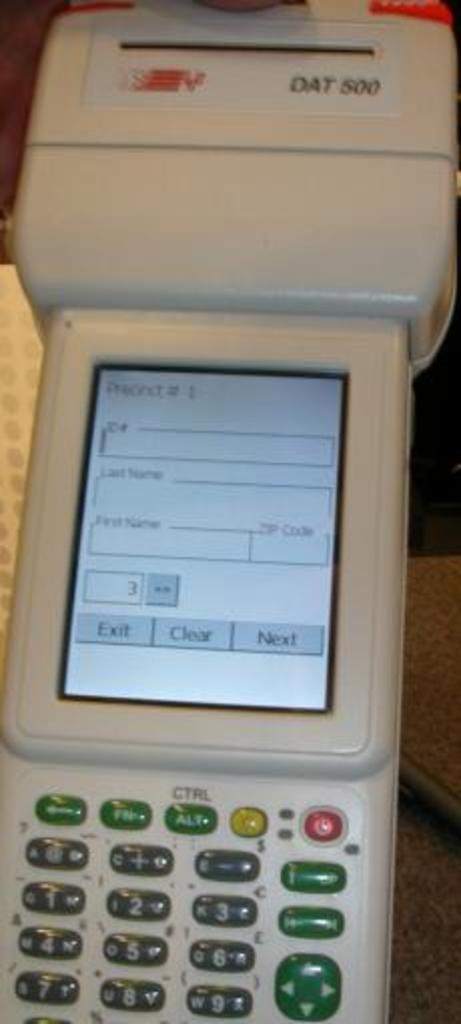<image>
Present a compact description of the photo's key features. A DAT 500 machine device that contains many small buttons on the bottom below a small screen. 